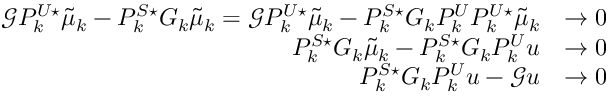Convert formula to latex. <formula><loc_0><loc_0><loc_500><loc_500>\begin{array} { r l } { \mathcal { G } P _ { k } ^ { U ^ { * } } \tilde { \mu } _ { k } - P _ { k } ^ { S ^ { * } } G _ { k } \tilde { \mu } _ { k } = \mathcal { G } P _ { k } ^ { U ^ { * } } \tilde { \mu } _ { k } - P _ { k } ^ { S ^ { * } } G _ { k } P _ { k } ^ { U } P _ { k } ^ { U ^ { * } } \tilde { \mu } _ { k } } & { \to 0 } \\ { P _ { k } ^ { S ^ { * } } G _ { k } \tilde { \mu } _ { k } - P _ { k } ^ { S ^ { * } } G _ { k } P _ { k } ^ { U } u } & { \to 0 } \\ { P _ { k } ^ { S ^ { * } } G _ { k } P _ { k } ^ { U } u - \mathcal { G } u } & { \to 0 } \end{array}</formula> 